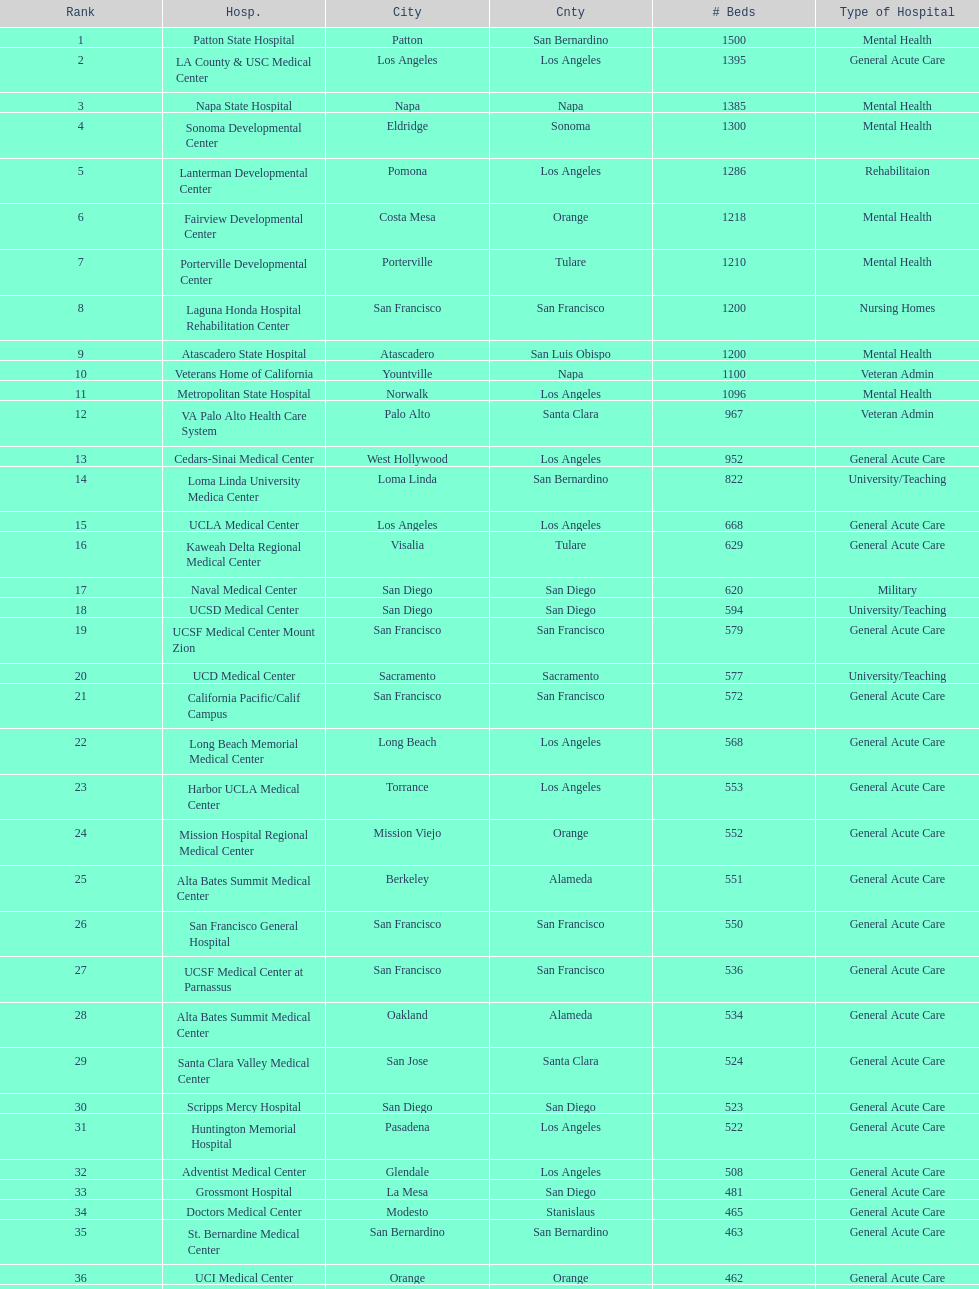Which type of hospitals are the same as grossmont hospital? General Acute Care. 